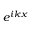Convert formula to latex. <formula><loc_0><loc_0><loc_500><loc_500>e ^ { i k x }</formula> 